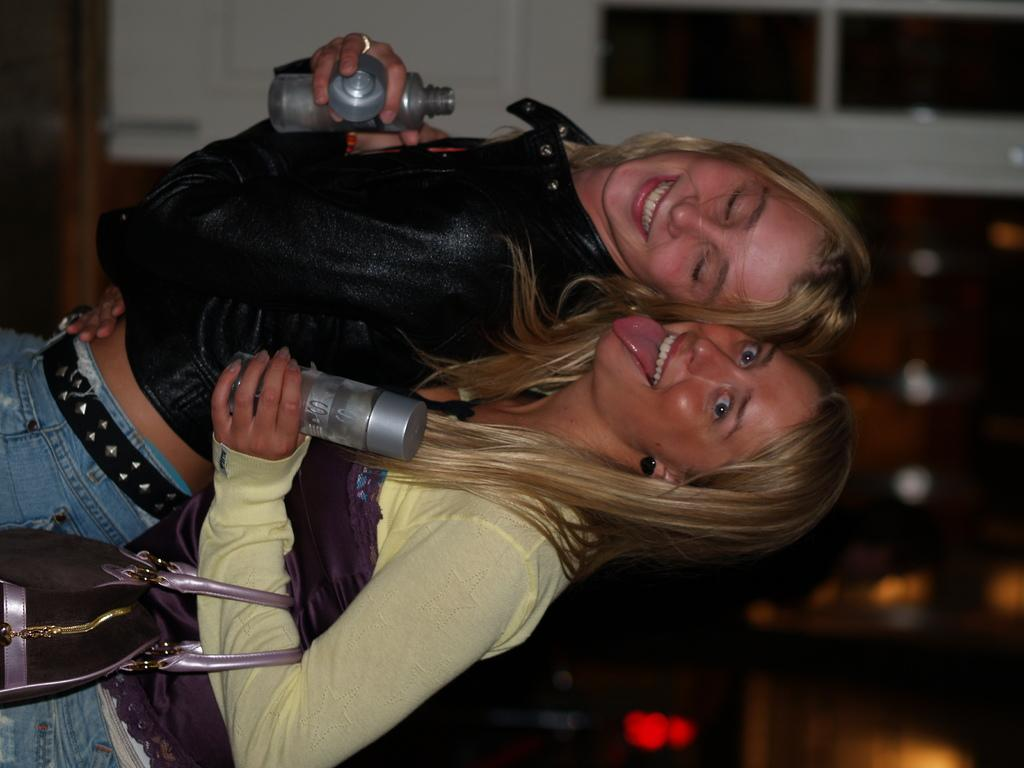How many girls are in the image? There are two girls in the image. What are the girls doing in the image? The girls are standing in the image. What are the girls holding in their hands? The girls are holding bottles in their hands. Is one of the girls holding anything else? Yes, one of the girls is holding a bag. What can be seen in the background of the image? There is a door and a wall in the background of the image. What type of beetle can be seen crawling on the wall in the image? There is no beetle present in the image; only the girls, bottles, bag, door, and wall are visible. What kind of beast is lurking behind the door in the image? There is no beast present in the image; only the girls, bottles, bag, door, and wall are visible. 